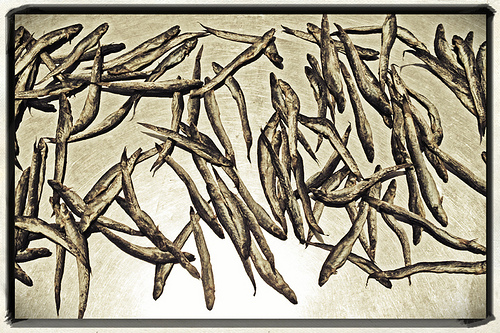<image>
Is the fish on the table? Yes. Looking at the image, I can see the fish is positioned on top of the table, with the table providing support. 